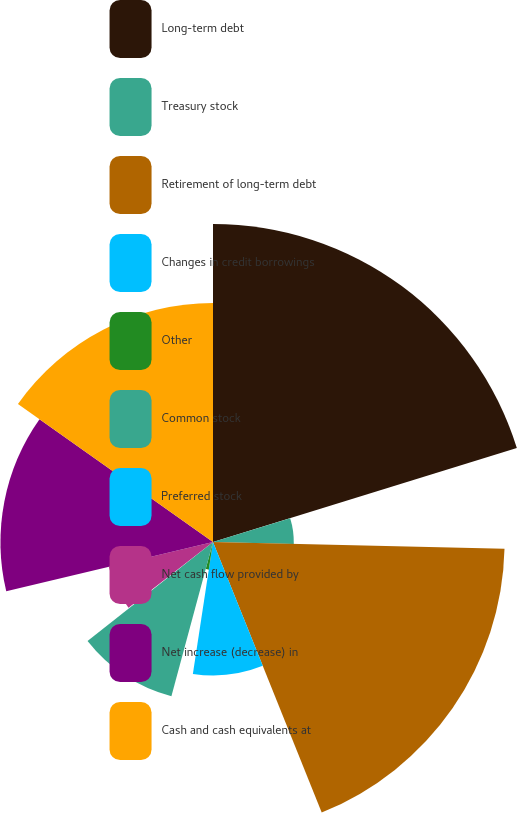Convert chart to OTSL. <chart><loc_0><loc_0><loc_500><loc_500><pie_chart><fcel>Long-term debt<fcel>Treasury stock<fcel>Retirement of long-term debt<fcel>Changes in credit borrowings<fcel>Other<fcel>Common stock<fcel>Preferred stock<fcel>Net cash flow provided by<fcel>Net increase (decrease) in<fcel>Cash and cash equivalents at<nl><fcel>20.23%<fcel>5.14%<fcel>18.55%<fcel>8.49%<fcel>1.78%<fcel>10.17%<fcel>0.11%<fcel>6.81%<fcel>13.52%<fcel>15.2%<nl></chart> 